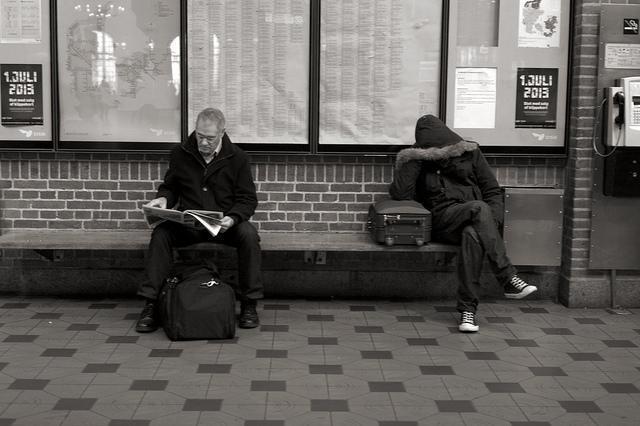How many people are visible?
Give a very brief answer. 2. 